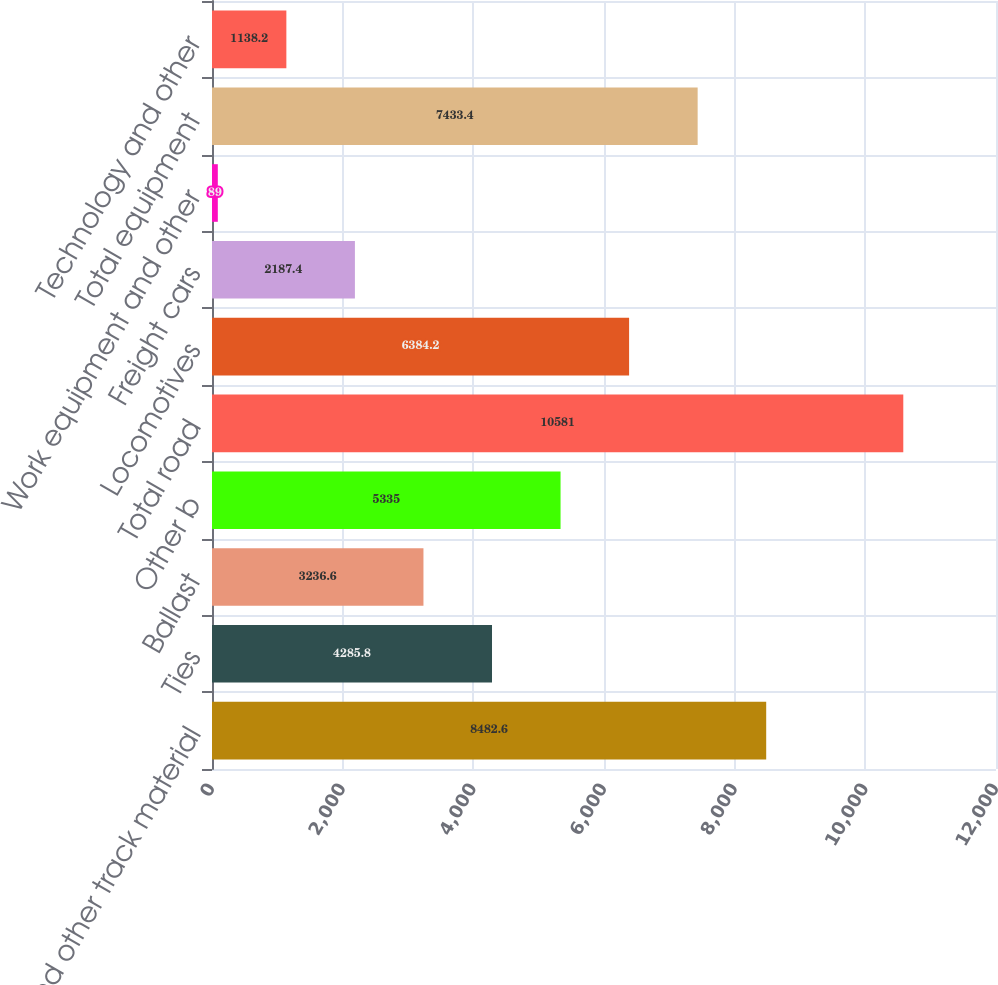Convert chart. <chart><loc_0><loc_0><loc_500><loc_500><bar_chart><fcel>Rail and other track material<fcel>Ties<fcel>Ballast<fcel>Other b<fcel>Total road<fcel>Locomotives<fcel>Freight cars<fcel>Work equipment and other<fcel>Total equipment<fcel>Technology and other<nl><fcel>8482.6<fcel>4285.8<fcel>3236.6<fcel>5335<fcel>10581<fcel>6384.2<fcel>2187.4<fcel>89<fcel>7433.4<fcel>1138.2<nl></chart> 